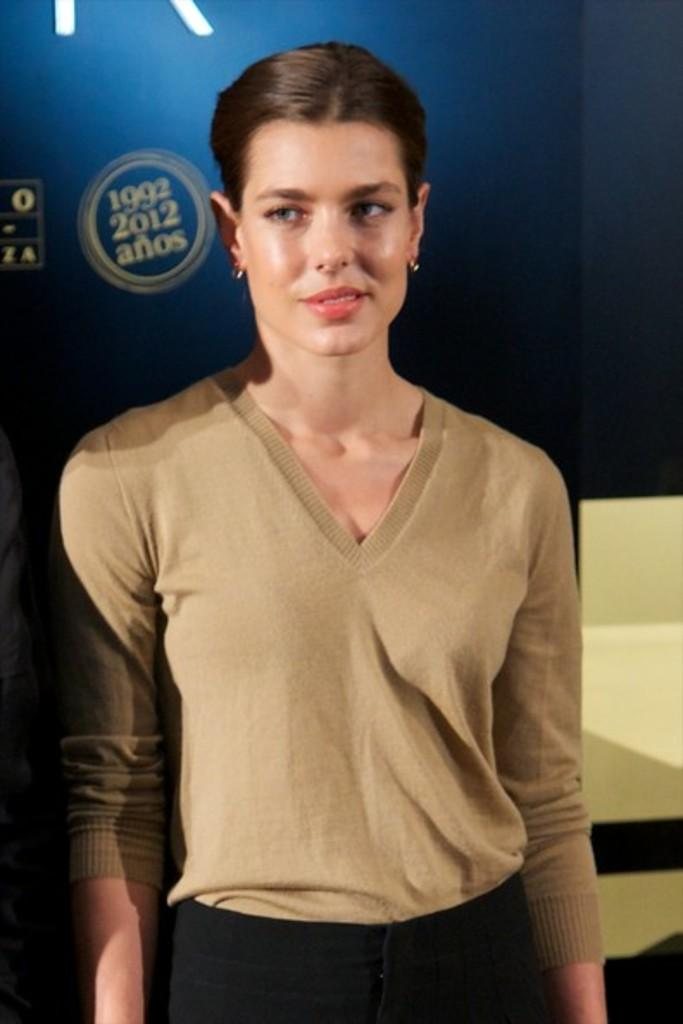Who is the main subject in the image? There is a woman in the image. What is the woman wearing? The woman is wearing a brown T-shirt and black pants. Where is the woman positioned in the image? The woman is standing in the middle of the image. What can be seen in the background of the image? There is a blue board with text in the background. What architectural feature is present beside the woman? There is a staircase beside the woman. What type of stew is being prepared on the blue board in the image? There is no stew present in the image; the blue board has text on it. What suggestion does the woman have for improving the image? The woman's suggestions cannot be determined from the image, as she is not making any gestures or expressions that indicate she has a suggestion. 